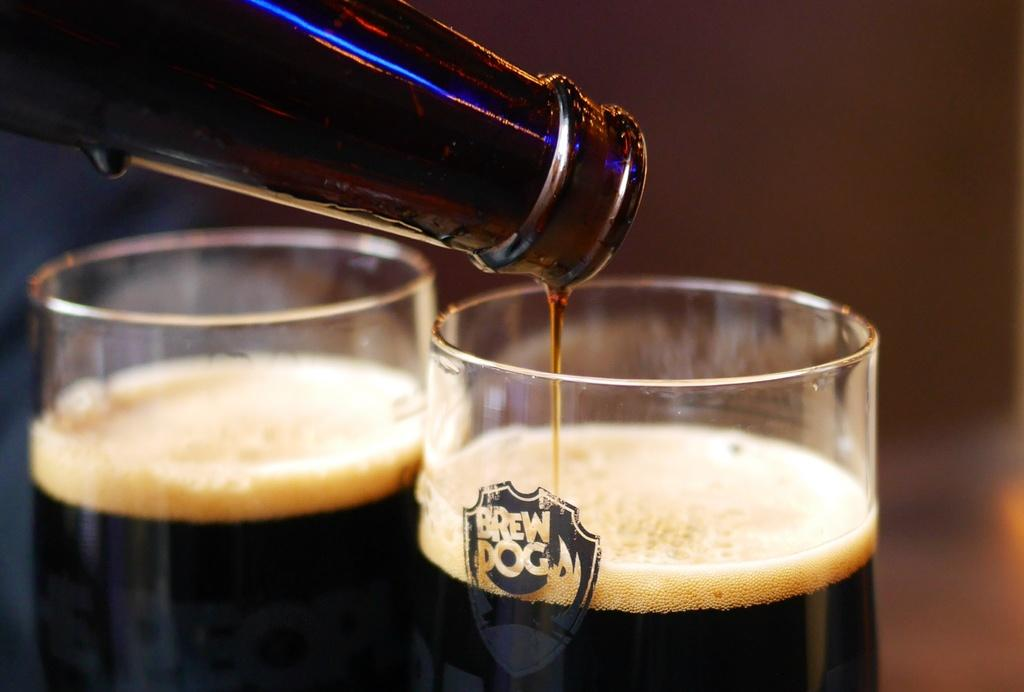<image>
Offer a succinct explanation of the picture presented. A bottle of beer is being poured into a Brew Dog glass. 